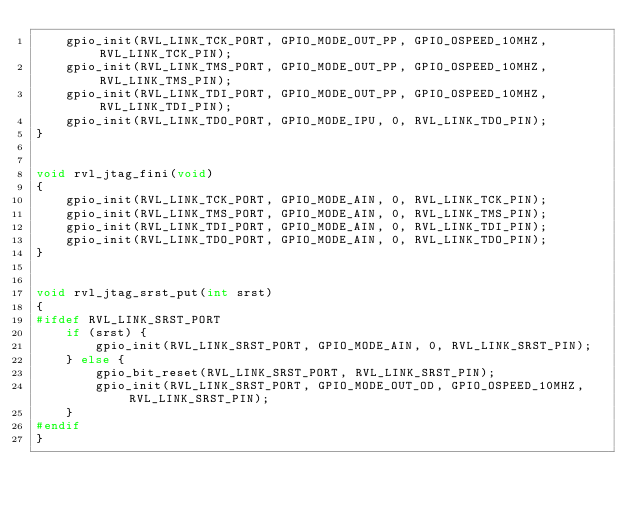<code> <loc_0><loc_0><loc_500><loc_500><_C_>    gpio_init(RVL_LINK_TCK_PORT, GPIO_MODE_OUT_PP, GPIO_OSPEED_10MHZ, RVL_LINK_TCK_PIN);
    gpio_init(RVL_LINK_TMS_PORT, GPIO_MODE_OUT_PP, GPIO_OSPEED_10MHZ, RVL_LINK_TMS_PIN);
    gpio_init(RVL_LINK_TDI_PORT, GPIO_MODE_OUT_PP, GPIO_OSPEED_10MHZ, RVL_LINK_TDI_PIN);
    gpio_init(RVL_LINK_TDO_PORT, GPIO_MODE_IPU, 0, RVL_LINK_TDO_PIN);
}


void rvl_jtag_fini(void)
{
    gpio_init(RVL_LINK_TCK_PORT, GPIO_MODE_AIN, 0, RVL_LINK_TCK_PIN);
    gpio_init(RVL_LINK_TMS_PORT, GPIO_MODE_AIN, 0, RVL_LINK_TMS_PIN);
    gpio_init(RVL_LINK_TDI_PORT, GPIO_MODE_AIN, 0, RVL_LINK_TDI_PIN);
    gpio_init(RVL_LINK_TDO_PORT, GPIO_MODE_AIN, 0, RVL_LINK_TDO_PIN);
}


void rvl_jtag_srst_put(int srst)
{
#ifdef RVL_LINK_SRST_PORT
    if (srst) {
        gpio_init(RVL_LINK_SRST_PORT, GPIO_MODE_AIN, 0, RVL_LINK_SRST_PIN);
    } else {
        gpio_bit_reset(RVL_LINK_SRST_PORT, RVL_LINK_SRST_PIN);
        gpio_init(RVL_LINK_SRST_PORT, GPIO_MODE_OUT_OD, GPIO_OSPEED_10MHZ, RVL_LINK_SRST_PIN);
    }
#endif
}
</code> 